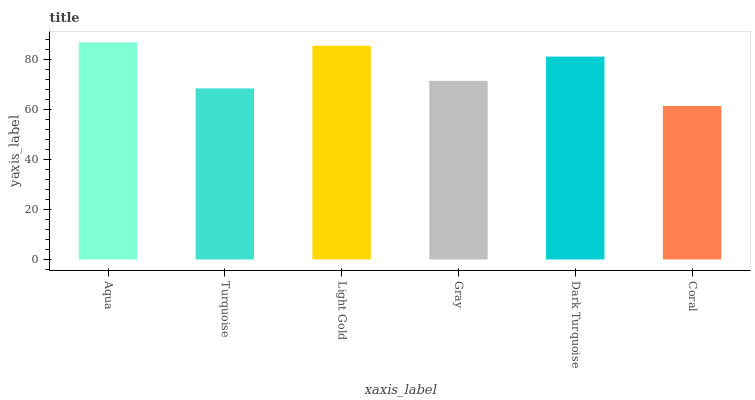Is Coral the minimum?
Answer yes or no. Yes. Is Aqua the maximum?
Answer yes or no. Yes. Is Turquoise the minimum?
Answer yes or no. No. Is Turquoise the maximum?
Answer yes or no. No. Is Aqua greater than Turquoise?
Answer yes or no. Yes. Is Turquoise less than Aqua?
Answer yes or no. Yes. Is Turquoise greater than Aqua?
Answer yes or no. No. Is Aqua less than Turquoise?
Answer yes or no. No. Is Dark Turquoise the high median?
Answer yes or no. Yes. Is Gray the low median?
Answer yes or no. Yes. Is Light Gold the high median?
Answer yes or no. No. Is Coral the low median?
Answer yes or no. No. 